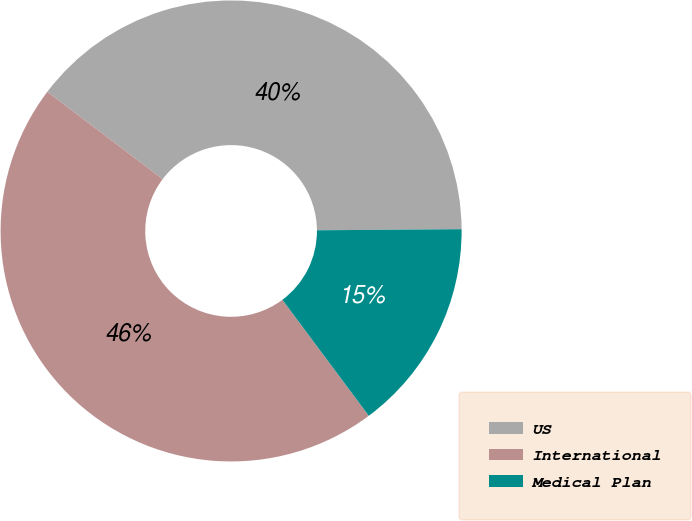<chart> <loc_0><loc_0><loc_500><loc_500><pie_chart><fcel>US<fcel>International<fcel>Medical Plan<nl><fcel>39.56%<fcel>45.5%<fcel>14.93%<nl></chart> 